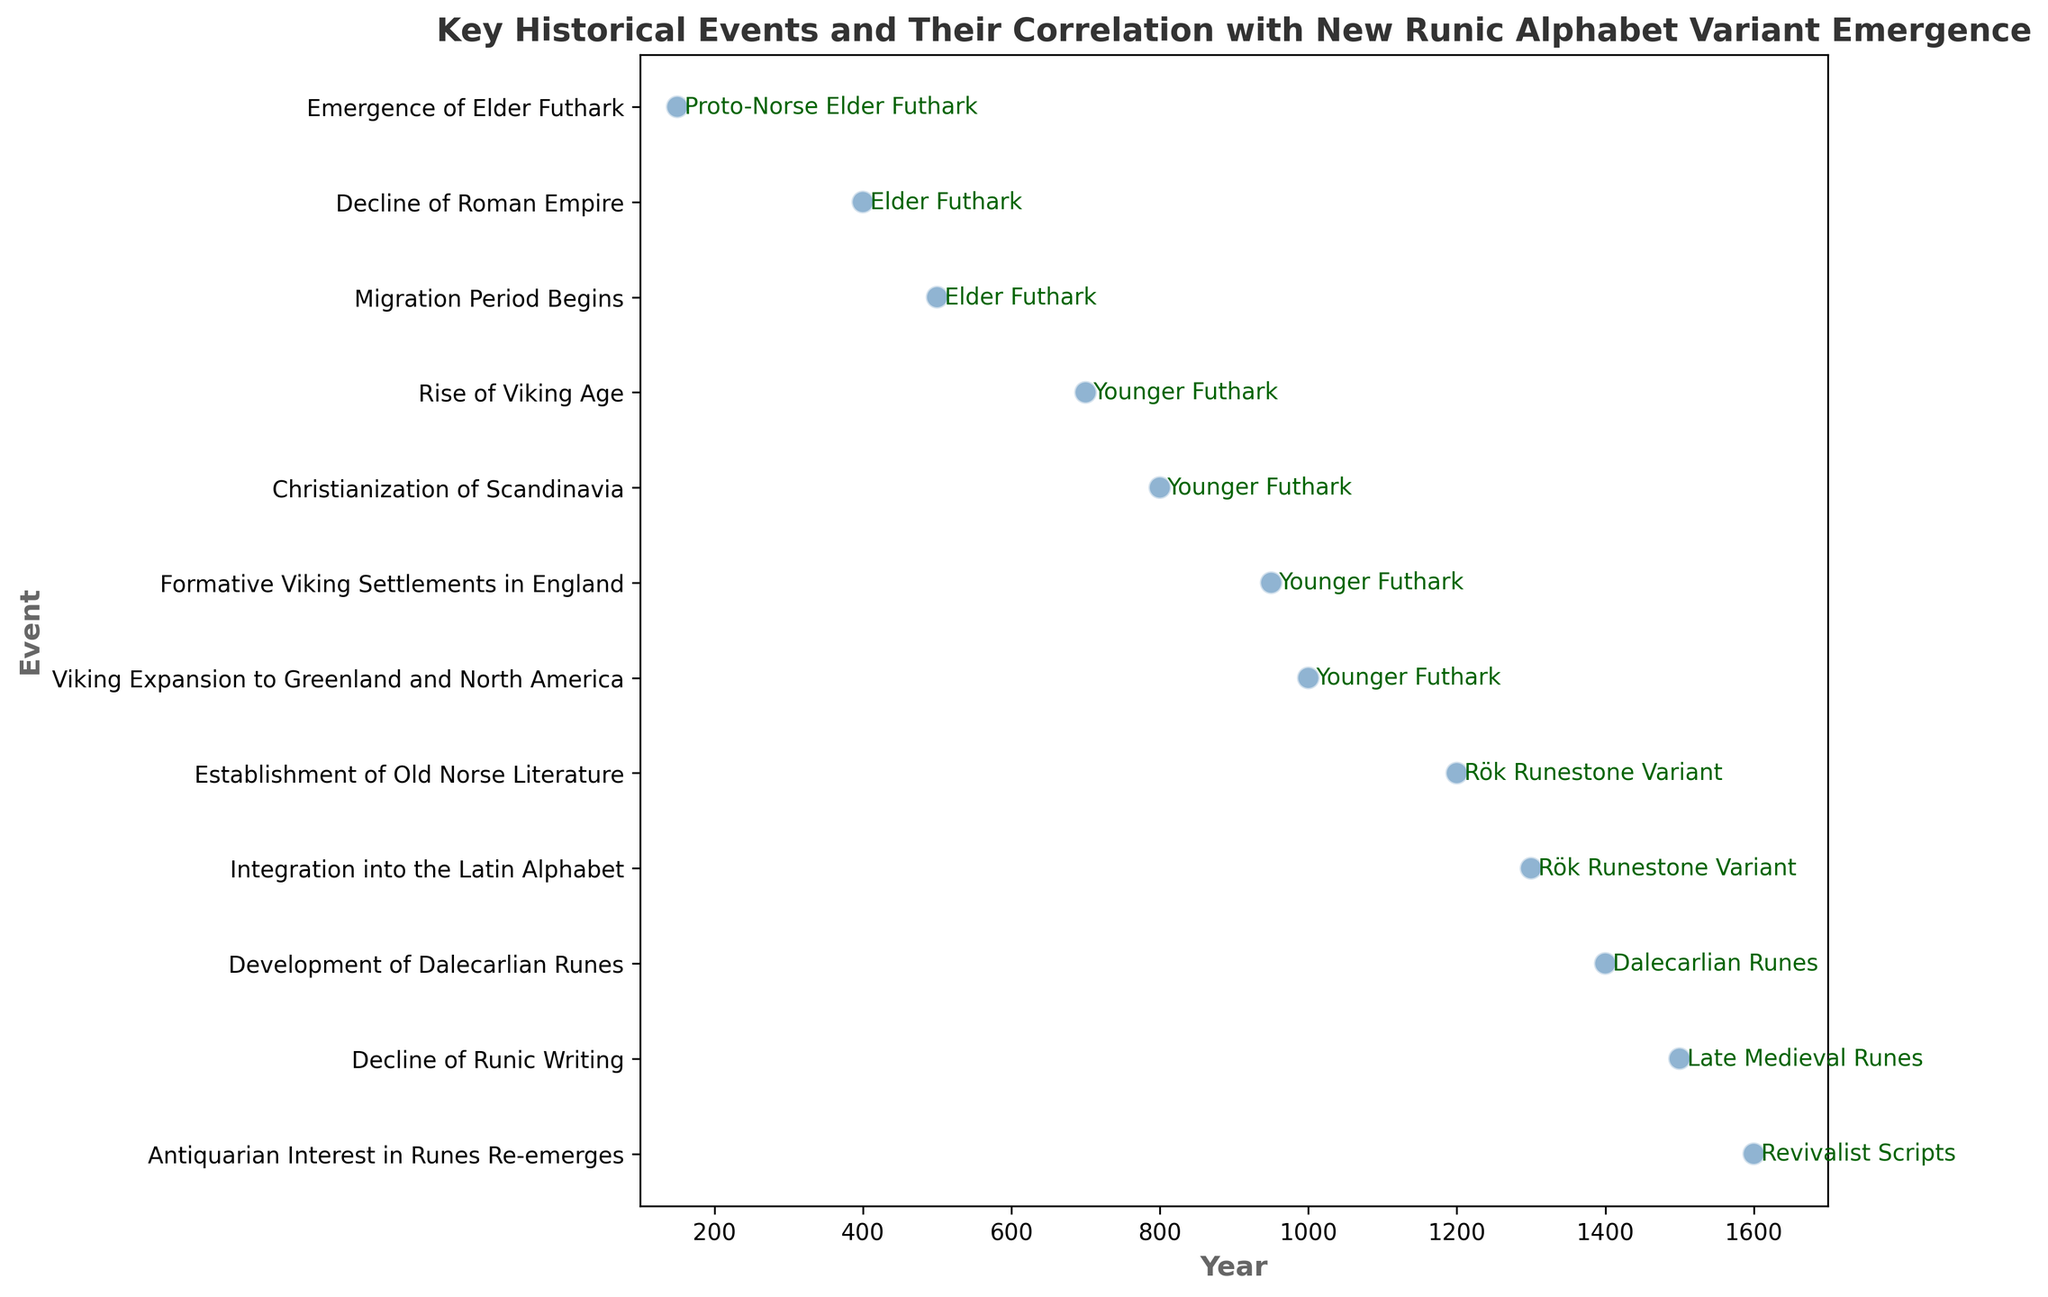What event corresponds to the emergence of Younger Futhark? The figure shows that the event "Rise of Viking Age" around the year 700 corresponds to the emergence of the Younger Futhark runic alphabet variant.
Answer: Rise of Viking Age Which runic alphabet variant is associated with the establishment of Old Norse Literature? By looking at the figure, it is evident that the establishment of Old Norse Literature around the year 1200 is associated with the Rök Runestone Variant.
Answer: Rök Runestone Variant What is the difference in years between the Christianization of Scandinavia and the Viking expansion to Greenland and North America? The figure shows that the Christianization of Scandinavia occurred around the year 800, and the Viking expansion to Greenland and North America occurred around the year 1000. The difference in years is 1000 - 800 = 200.
Answer: 200 years Compare the timing of the decline of the Roman Empire and the Migration Period. Which occurred first? According to the figure, the decline of the Roman Empire occurred around the year 400, while the Migration Period began around the year 500. Therefore, the decline of the Roman Empire occurred first.
Answer: Decline of Roman Empire Which runic alphabet variant was used during the Rise of Viking Age, and what variant replaced it by the development of Dalecarlian Runes era? The figure indicates that the Younger Futhark was used during the Rise of Viking Age around the year 700. By the development of Dalecarlian Runes around the year 1400, the runic alphabet variant had changed to Dalecarlian Runes.
Answer: Younger Futhark, Dalecarlian Runes What is the time interval between the emergence of Elder Futhark and the establishment of the Dalecarlian Runes? According to the figure, the emergence of Elder Futhark took place around the year 150, and the establishment of Dalecarlian Runes occurred around the year 1400. The time interval between these two events is 1400 - 150 = 1250 years.
Answer: 1250 years Visually, what color and shape are used to represent the events on the plot? The plot uses steel blue circles to represent the events, with each event marked along the timeline. The circles have a white edge and a 1.2 linewidth.
Answer: Steel blue circles Which event marks the integration of the runic alphabet into the Latin alphabet and what time period does this occur? The figure shows that the event marking the integration of the runic alphabet into the Latin alphabet is "Integration into the Latin Alphabet," which occurs around the year 1300.
Answer: Integration into the Latin Alphabet, around the year 1300 Which runic alphabet variant was present during the Viking expansion to Greenland and North America? The figure indicates that the Younger Futhark was the runic alphabet variant present during the Viking expansion to Greenland and North America around the year 1000.
Answer: Younger Futhark 